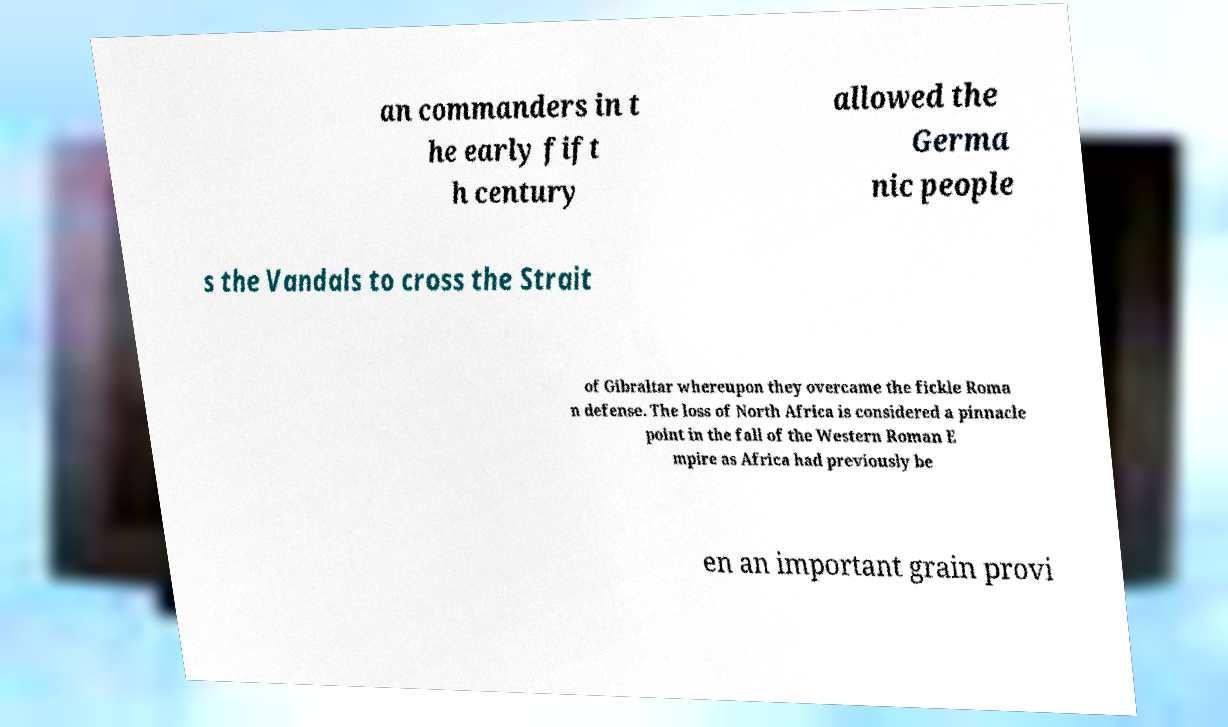Please read and relay the text visible in this image. What does it say? an commanders in t he early fift h century allowed the Germa nic people s the Vandals to cross the Strait of Gibraltar whereupon they overcame the fickle Roma n defense. The loss of North Africa is considered a pinnacle point in the fall of the Western Roman E mpire as Africa had previously be en an important grain provi 